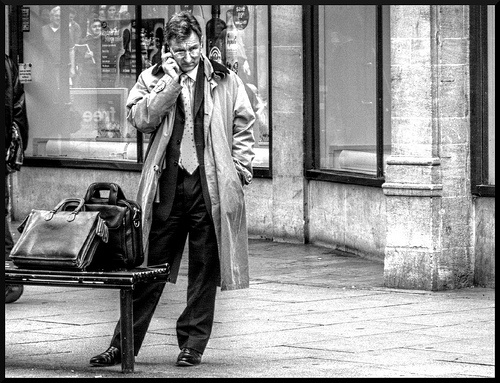Describe the objects in this image and their specific colors. I can see people in black, darkgray, lightgray, and gray tones, handbag in black, darkgray, gray, and lightgray tones, bench in black, gray, darkgray, and lightgray tones, suitcase in black, gray, darkgray, and lightgray tones, and handbag in black, gray, darkgray, and lightgray tones in this image. 